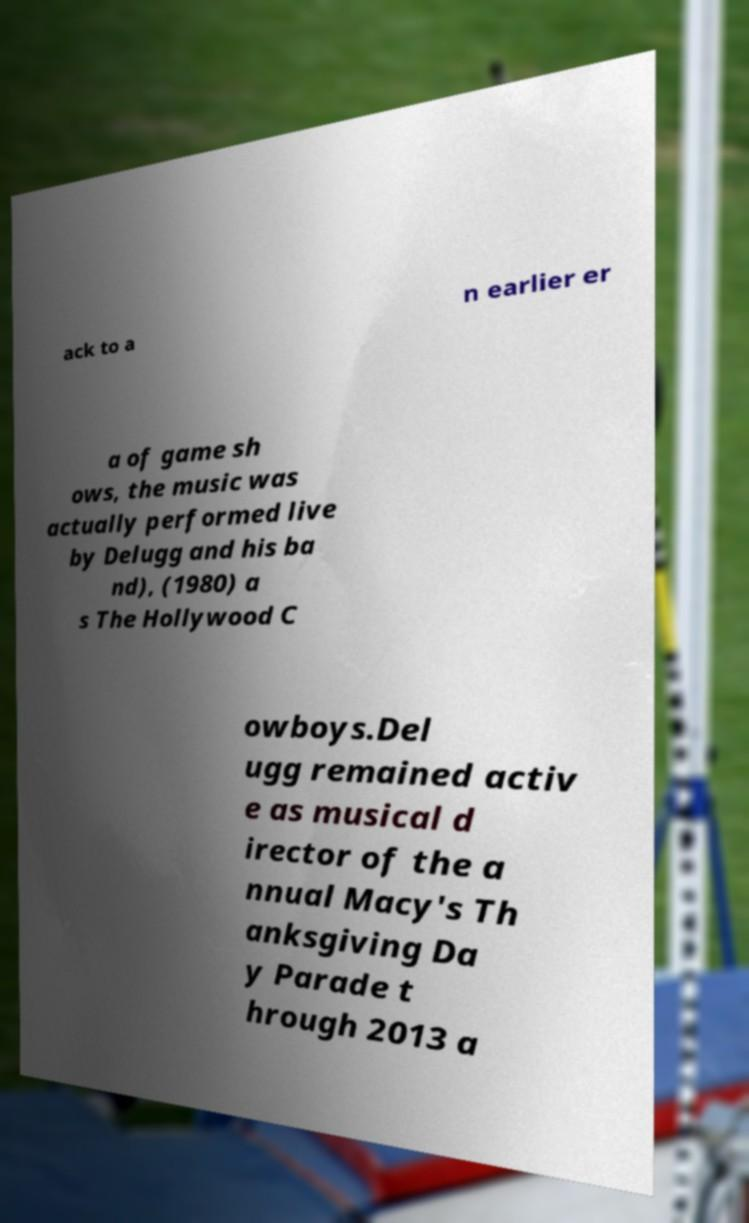Could you extract and type out the text from this image? ack to a n earlier er a of game sh ows, the music was actually performed live by Delugg and his ba nd), (1980) a s The Hollywood C owboys.Del ugg remained activ e as musical d irector of the a nnual Macy's Th anksgiving Da y Parade t hrough 2013 a 